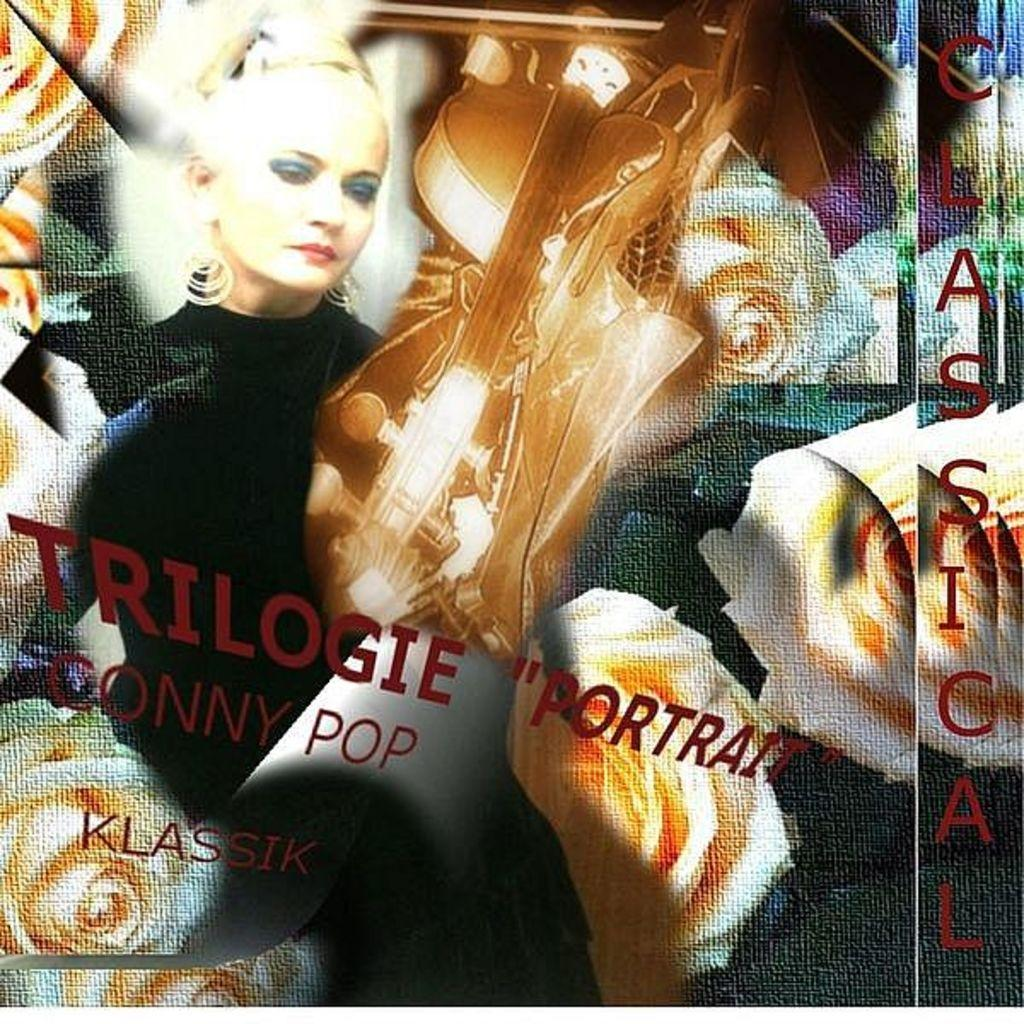What is depicted in the painting in the image? There is a painting of a person in the image. What musical instrument can be seen in the image? There is a guitar in the image. What type of flora is present in the image? There are flowers in the image. What type of cake is being served in the image? There is no cake present in the image; it features a painting, a guitar, and flowers. What type of print is visible on the guitar in the image? The image does not show any print on the guitar; it only shows the guitar itself. 